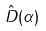Convert formula to latex. <formula><loc_0><loc_0><loc_500><loc_500>\hat { D } ( \alpha )</formula> 